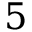Convert formula to latex. <formula><loc_0><loc_0><loc_500><loc_500>5</formula> 